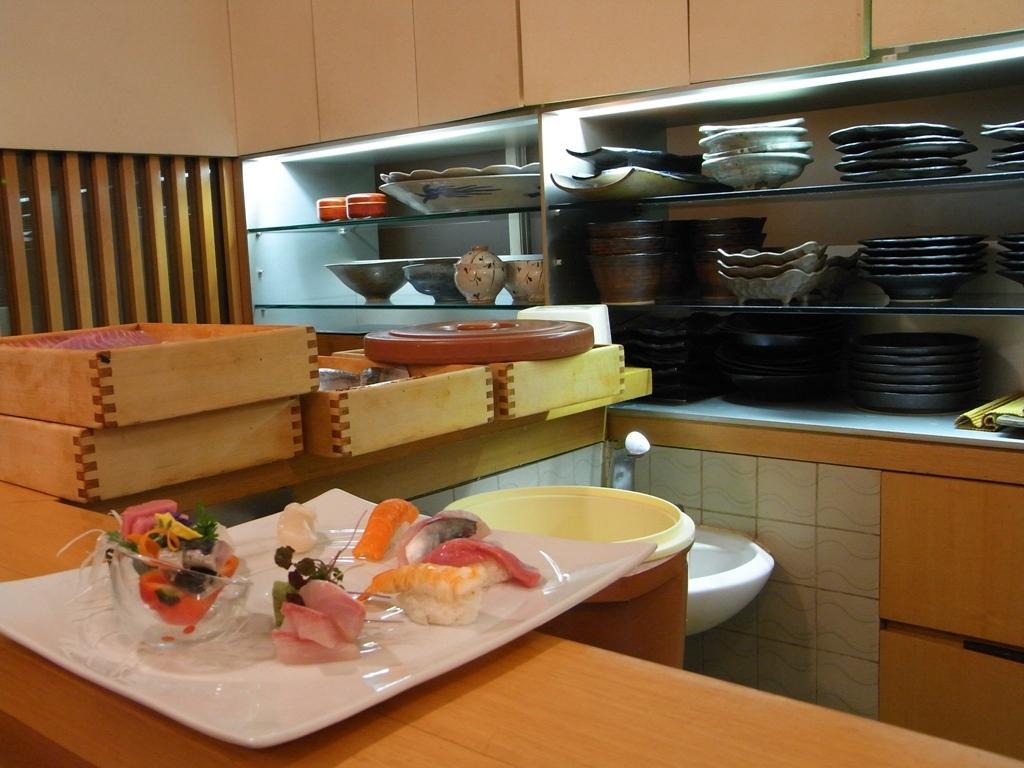How would you summarize this image in a sentence or two? Here in this picture in the front we can see a plate with food items present on table over there and beside that we can see some boxes present and in the racks present over there we can see number of different kind of plate, bowls and trays present in that over there and in the middle we can see a sink with a tap present and beside it we can see a bucket present over there. 